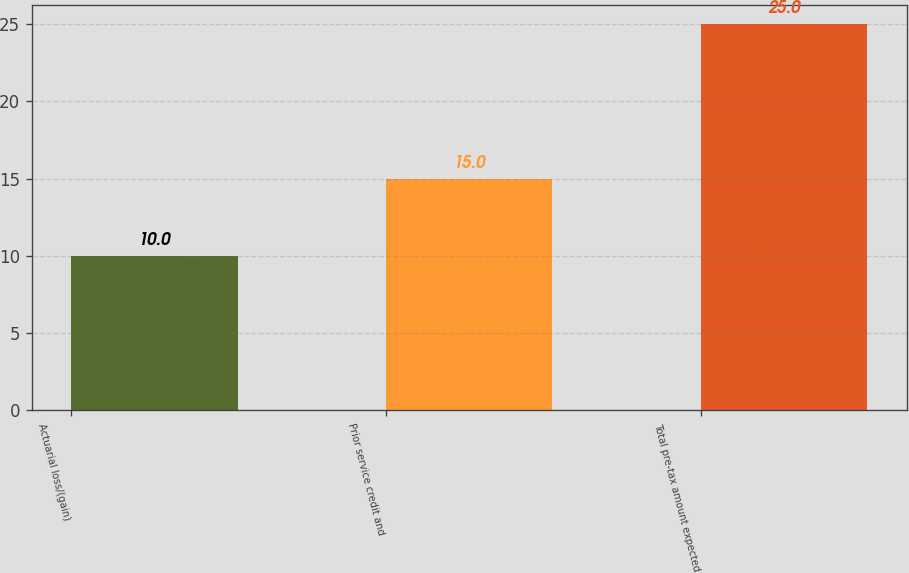<chart> <loc_0><loc_0><loc_500><loc_500><bar_chart><fcel>Actuarial loss/(gain)<fcel>Prior service credit and<fcel>Total pre-tax amount expected<nl><fcel>10<fcel>15<fcel>25<nl></chart> 